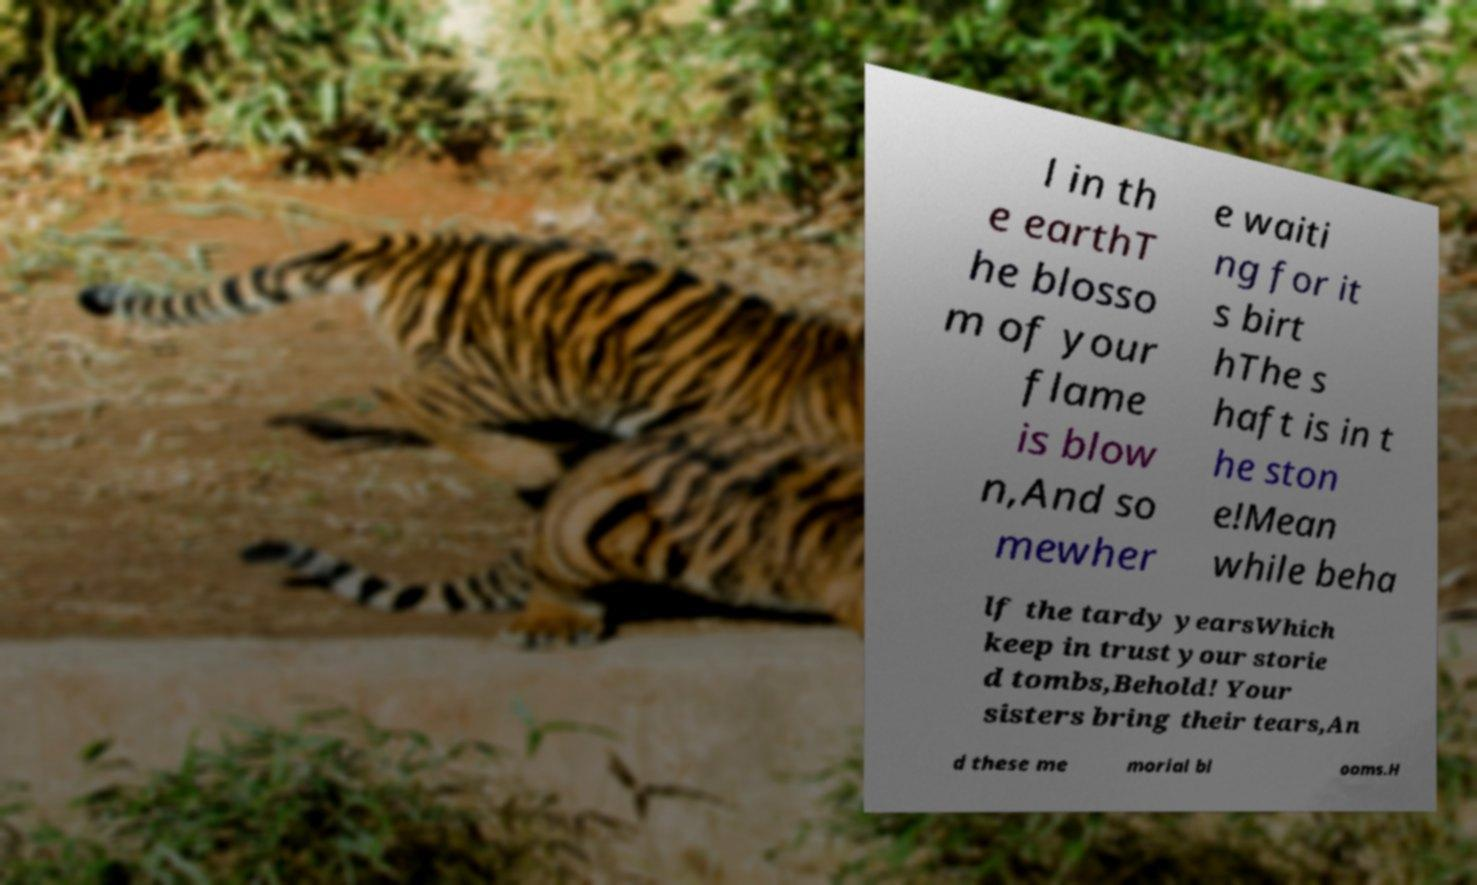Can you accurately transcribe the text from the provided image for me? l in th e earthT he blosso m of your flame is blow n,And so mewher e waiti ng for it s birt hThe s haft is in t he ston e!Mean while beha lf the tardy yearsWhich keep in trust your storie d tombs,Behold! Your sisters bring their tears,An d these me morial bl ooms.H 